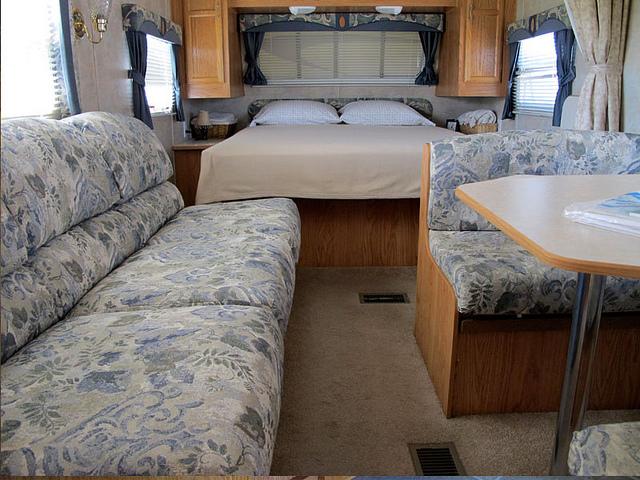What color are the cushions?
Quick response, please. Gray and blue. What number of furniture pieces are in here?
Be succinct. 4. Where was this taken?
Keep it brief. Rv. What color is the furniture?
Concise answer only. Blue. 